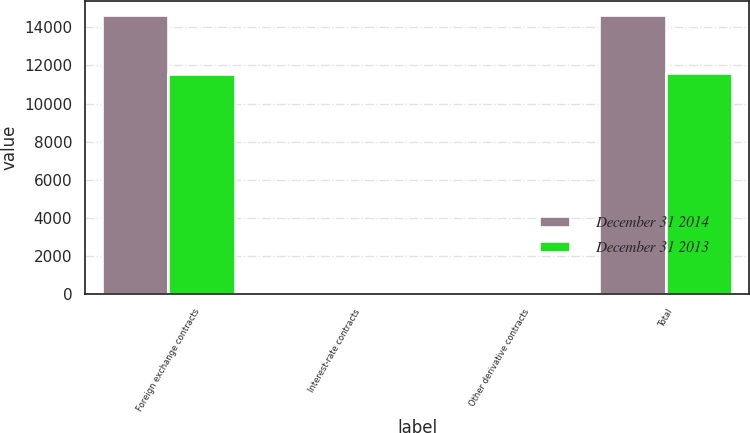Convert chart. <chart><loc_0><loc_0><loc_500><loc_500><stacked_bar_chart><ecel><fcel>Foreign exchange contracts<fcel>Interest-rate contracts<fcel>Other derivative contracts<fcel>Total<nl><fcel>December 31 2014<fcel>14626<fcel>15<fcel>2<fcel>14643<nl><fcel>December 31 2013<fcel>11552<fcel>29<fcel>1<fcel>11582<nl></chart> 